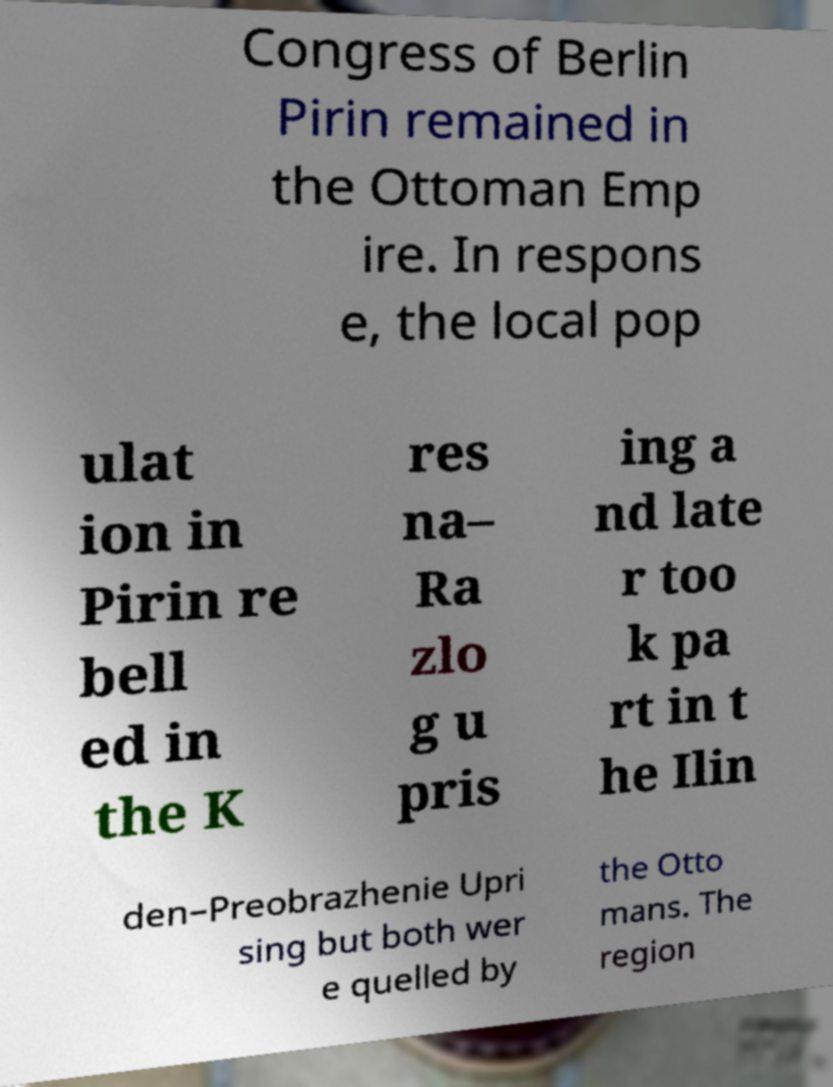Please identify and transcribe the text found in this image. Congress of Berlin Pirin remained in the Ottoman Emp ire. In respons e, the local pop ulat ion in Pirin re bell ed in the K res na– Ra zlo g u pris ing a nd late r too k pa rt in t he Ilin den–Preobrazhenie Upri sing but both wer e quelled by the Otto mans. The region 